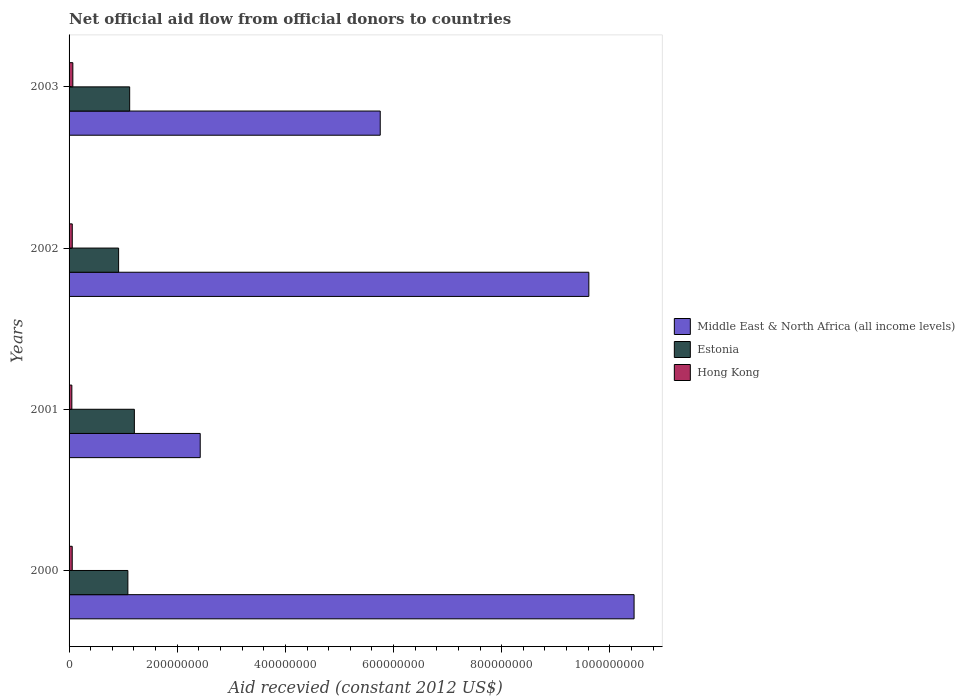How many different coloured bars are there?
Make the answer very short. 3. How many groups of bars are there?
Provide a succinct answer. 4. Are the number of bars per tick equal to the number of legend labels?
Your answer should be compact. Yes. What is the label of the 2nd group of bars from the top?
Offer a terse response. 2002. In how many cases, is the number of bars for a given year not equal to the number of legend labels?
Provide a succinct answer. 0. What is the total aid received in Hong Kong in 2003?
Keep it short and to the point. 6.99e+06. Across all years, what is the maximum total aid received in Hong Kong?
Ensure brevity in your answer.  6.99e+06. Across all years, what is the minimum total aid received in Estonia?
Make the answer very short. 9.16e+07. In which year was the total aid received in Hong Kong minimum?
Make the answer very short. 2001. What is the total total aid received in Hong Kong in the graph?
Your answer should be compact. 2.39e+07. What is the difference between the total aid received in Middle East & North Africa (all income levels) in 2001 and that in 2002?
Make the answer very short. -7.19e+08. What is the difference between the total aid received in Middle East & North Africa (all income levels) in 2001 and the total aid received in Hong Kong in 2002?
Your response must be concise. 2.37e+08. What is the average total aid received in Hong Kong per year?
Ensure brevity in your answer.  5.96e+06. In the year 2003, what is the difference between the total aid received in Hong Kong and total aid received in Middle East & North Africa (all income levels)?
Your answer should be very brief. -5.68e+08. In how many years, is the total aid received in Hong Kong greater than 840000000 US$?
Offer a terse response. 0. What is the ratio of the total aid received in Estonia in 2000 to that in 2001?
Provide a short and direct response. 0.9. Is the total aid received in Estonia in 2000 less than that in 2001?
Keep it short and to the point. Yes. Is the difference between the total aid received in Hong Kong in 2002 and 2003 greater than the difference between the total aid received in Middle East & North Africa (all income levels) in 2002 and 2003?
Offer a very short reply. No. What is the difference between the highest and the second highest total aid received in Hong Kong?
Ensure brevity in your answer.  1.07e+06. What is the difference between the highest and the lowest total aid received in Estonia?
Your answer should be compact. 2.91e+07. In how many years, is the total aid received in Estonia greater than the average total aid received in Estonia taken over all years?
Your response must be concise. 3. What does the 2nd bar from the top in 2001 represents?
Give a very brief answer. Estonia. What does the 2nd bar from the bottom in 2001 represents?
Offer a very short reply. Estonia. Does the graph contain any zero values?
Give a very brief answer. No. What is the title of the graph?
Ensure brevity in your answer.  Net official aid flow from official donors to countries. Does "Kiribati" appear as one of the legend labels in the graph?
Offer a very short reply. No. What is the label or title of the X-axis?
Give a very brief answer. Aid recevied (constant 2012 US$). What is the Aid recevied (constant 2012 US$) of Middle East & North Africa (all income levels) in 2000?
Make the answer very short. 1.04e+09. What is the Aid recevied (constant 2012 US$) of Estonia in 2000?
Provide a short and direct response. 1.09e+08. What is the Aid recevied (constant 2012 US$) of Hong Kong in 2000?
Offer a very short reply. 5.83e+06. What is the Aid recevied (constant 2012 US$) in Middle East & North Africa (all income levels) in 2001?
Your answer should be very brief. 2.43e+08. What is the Aid recevied (constant 2012 US$) in Estonia in 2001?
Make the answer very short. 1.21e+08. What is the Aid recevied (constant 2012 US$) of Hong Kong in 2001?
Give a very brief answer. 5.12e+06. What is the Aid recevied (constant 2012 US$) of Middle East & North Africa (all income levels) in 2002?
Keep it short and to the point. 9.61e+08. What is the Aid recevied (constant 2012 US$) of Estonia in 2002?
Your response must be concise. 9.16e+07. What is the Aid recevied (constant 2012 US$) in Hong Kong in 2002?
Make the answer very short. 5.92e+06. What is the Aid recevied (constant 2012 US$) in Middle East & North Africa (all income levels) in 2003?
Your response must be concise. 5.75e+08. What is the Aid recevied (constant 2012 US$) in Estonia in 2003?
Ensure brevity in your answer.  1.12e+08. What is the Aid recevied (constant 2012 US$) in Hong Kong in 2003?
Give a very brief answer. 6.99e+06. Across all years, what is the maximum Aid recevied (constant 2012 US$) in Middle East & North Africa (all income levels)?
Provide a short and direct response. 1.04e+09. Across all years, what is the maximum Aid recevied (constant 2012 US$) in Estonia?
Provide a succinct answer. 1.21e+08. Across all years, what is the maximum Aid recevied (constant 2012 US$) of Hong Kong?
Give a very brief answer. 6.99e+06. Across all years, what is the minimum Aid recevied (constant 2012 US$) in Middle East & North Africa (all income levels)?
Your response must be concise. 2.43e+08. Across all years, what is the minimum Aid recevied (constant 2012 US$) in Estonia?
Offer a terse response. 9.16e+07. Across all years, what is the minimum Aid recevied (constant 2012 US$) of Hong Kong?
Ensure brevity in your answer.  5.12e+06. What is the total Aid recevied (constant 2012 US$) of Middle East & North Africa (all income levels) in the graph?
Your answer should be very brief. 2.82e+09. What is the total Aid recevied (constant 2012 US$) of Estonia in the graph?
Your answer should be compact. 4.33e+08. What is the total Aid recevied (constant 2012 US$) of Hong Kong in the graph?
Offer a very short reply. 2.39e+07. What is the difference between the Aid recevied (constant 2012 US$) in Middle East & North Africa (all income levels) in 2000 and that in 2001?
Offer a terse response. 8.02e+08. What is the difference between the Aid recevied (constant 2012 US$) in Estonia in 2000 and that in 2001?
Ensure brevity in your answer.  -1.20e+07. What is the difference between the Aid recevied (constant 2012 US$) in Hong Kong in 2000 and that in 2001?
Offer a terse response. 7.10e+05. What is the difference between the Aid recevied (constant 2012 US$) of Middle East & North Africa (all income levels) in 2000 and that in 2002?
Ensure brevity in your answer.  8.36e+07. What is the difference between the Aid recevied (constant 2012 US$) in Estonia in 2000 and that in 2002?
Your answer should be compact. 1.71e+07. What is the difference between the Aid recevied (constant 2012 US$) of Middle East & North Africa (all income levels) in 2000 and that in 2003?
Offer a terse response. 4.69e+08. What is the difference between the Aid recevied (constant 2012 US$) of Estonia in 2000 and that in 2003?
Give a very brief answer. -3.35e+06. What is the difference between the Aid recevied (constant 2012 US$) of Hong Kong in 2000 and that in 2003?
Keep it short and to the point. -1.16e+06. What is the difference between the Aid recevied (constant 2012 US$) in Middle East & North Africa (all income levels) in 2001 and that in 2002?
Your response must be concise. -7.19e+08. What is the difference between the Aid recevied (constant 2012 US$) in Estonia in 2001 and that in 2002?
Provide a short and direct response. 2.91e+07. What is the difference between the Aid recevied (constant 2012 US$) of Hong Kong in 2001 and that in 2002?
Give a very brief answer. -8.00e+05. What is the difference between the Aid recevied (constant 2012 US$) of Middle East & North Africa (all income levels) in 2001 and that in 2003?
Make the answer very short. -3.33e+08. What is the difference between the Aid recevied (constant 2012 US$) of Estonia in 2001 and that in 2003?
Provide a short and direct response. 8.66e+06. What is the difference between the Aid recevied (constant 2012 US$) of Hong Kong in 2001 and that in 2003?
Offer a terse response. -1.87e+06. What is the difference between the Aid recevied (constant 2012 US$) of Middle East & North Africa (all income levels) in 2002 and that in 2003?
Offer a terse response. 3.86e+08. What is the difference between the Aid recevied (constant 2012 US$) in Estonia in 2002 and that in 2003?
Offer a very short reply. -2.05e+07. What is the difference between the Aid recevied (constant 2012 US$) of Hong Kong in 2002 and that in 2003?
Make the answer very short. -1.07e+06. What is the difference between the Aid recevied (constant 2012 US$) of Middle East & North Africa (all income levels) in 2000 and the Aid recevied (constant 2012 US$) of Estonia in 2001?
Keep it short and to the point. 9.24e+08. What is the difference between the Aid recevied (constant 2012 US$) in Middle East & North Africa (all income levels) in 2000 and the Aid recevied (constant 2012 US$) in Hong Kong in 2001?
Your response must be concise. 1.04e+09. What is the difference between the Aid recevied (constant 2012 US$) of Estonia in 2000 and the Aid recevied (constant 2012 US$) of Hong Kong in 2001?
Your answer should be very brief. 1.04e+08. What is the difference between the Aid recevied (constant 2012 US$) of Middle East & North Africa (all income levels) in 2000 and the Aid recevied (constant 2012 US$) of Estonia in 2002?
Provide a succinct answer. 9.53e+08. What is the difference between the Aid recevied (constant 2012 US$) of Middle East & North Africa (all income levels) in 2000 and the Aid recevied (constant 2012 US$) of Hong Kong in 2002?
Make the answer very short. 1.04e+09. What is the difference between the Aid recevied (constant 2012 US$) of Estonia in 2000 and the Aid recevied (constant 2012 US$) of Hong Kong in 2002?
Your answer should be very brief. 1.03e+08. What is the difference between the Aid recevied (constant 2012 US$) in Middle East & North Africa (all income levels) in 2000 and the Aid recevied (constant 2012 US$) in Estonia in 2003?
Keep it short and to the point. 9.33e+08. What is the difference between the Aid recevied (constant 2012 US$) of Middle East & North Africa (all income levels) in 2000 and the Aid recevied (constant 2012 US$) of Hong Kong in 2003?
Offer a terse response. 1.04e+09. What is the difference between the Aid recevied (constant 2012 US$) in Estonia in 2000 and the Aid recevied (constant 2012 US$) in Hong Kong in 2003?
Your answer should be compact. 1.02e+08. What is the difference between the Aid recevied (constant 2012 US$) of Middle East & North Africa (all income levels) in 2001 and the Aid recevied (constant 2012 US$) of Estonia in 2002?
Make the answer very short. 1.51e+08. What is the difference between the Aid recevied (constant 2012 US$) of Middle East & North Africa (all income levels) in 2001 and the Aid recevied (constant 2012 US$) of Hong Kong in 2002?
Your answer should be compact. 2.37e+08. What is the difference between the Aid recevied (constant 2012 US$) in Estonia in 2001 and the Aid recevied (constant 2012 US$) in Hong Kong in 2002?
Offer a terse response. 1.15e+08. What is the difference between the Aid recevied (constant 2012 US$) in Middle East & North Africa (all income levels) in 2001 and the Aid recevied (constant 2012 US$) in Estonia in 2003?
Provide a short and direct response. 1.30e+08. What is the difference between the Aid recevied (constant 2012 US$) of Middle East & North Africa (all income levels) in 2001 and the Aid recevied (constant 2012 US$) of Hong Kong in 2003?
Give a very brief answer. 2.36e+08. What is the difference between the Aid recevied (constant 2012 US$) of Estonia in 2001 and the Aid recevied (constant 2012 US$) of Hong Kong in 2003?
Your answer should be compact. 1.14e+08. What is the difference between the Aid recevied (constant 2012 US$) of Middle East & North Africa (all income levels) in 2002 and the Aid recevied (constant 2012 US$) of Estonia in 2003?
Ensure brevity in your answer.  8.49e+08. What is the difference between the Aid recevied (constant 2012 US$) of Middle East & North Africa (all income levels) in 2002 and the Aid recevied (constant 2012 US$) of Hong Kong in 2003?
Provide a short and direct response. 9.54e+08. What is the difference between the Aid recevied (constant 2012 US$) in Estonia in 2002 and the Aid recevied (constant 2012 US$) in Hong Kong in 2003?
Provide a short and direct response. 8.46e+07. What is the average Aid recevied (constant 2012 US$) of Middle East & North Africa (all income levels) per year?
Provide a succinct answer. 7.06e+08. What is the average Aid recevied (constant 2012 US$) in Estonia per year?
Provide a short and direct response. 1.08e+08. What is the average Aid recevied (constant 2012 US$) in Hong Kong per year?
Offer a very short reply. 5.96e+06. In the year 2000, what is the difference between the Aid recevied (constant 2012 US$) of Middle East & North Africa (all income levels) and Aid recevied (constant 2012 US$) of Estonia?
Your answer should be compact. 9.36e+08. In the year 2000, what is the difference between the Aid recevied (constant 2012 US$) in Middle East & North Africa (all income levels) and Aid recevied (constant 2012 US$) in Hong Kong?
Your answer should be very brief. 1.04e+09. In the year 2000, what is the difference between the Aid recevied (constant 2012 US$) of Estonia and Aid recevied (constant 2012 US$) of Hong Kong?
Provide a short and direct response. 1.03e+08. In the year 2001, what is the difference between the Aid recevied (constant 2012 US$) of Middle East & North Africa (all income levels) and Aid recevied (constant 2012 US$) of Estonia?
Provide a short and direct response. 1.22e+08. In the year 2001, what is the difference between the Aid recevied (constant 2012 US$) of Middle East & North Africa (all income levels) and Aid recevied (constant 2012 US$) of Hong Kong?
Give a very brief answer. 2.37e+08. In the year 2001, what is the difference between the Aid recevied (constant 2012 US$) in Estonia and Aid recevied (constant 2012 US$) in Hong Kong?
Keep it short and to the point. 1.16e+08. In the year 2002, what is the difference between the Aid recevied (constant 2012 US$) in Middle East & North Africa (all income levels) and Aid recevied (constant 2012 US$) in Estonia?
Provide a short and direct response. 8.70e+08. In the year 2002, what is the difference between the Aid recevied (constant 2012 US$) of Middle East & North Africa (all income levels) and Aid recevied (constant 2012 US$) of Hong Kong?
Give a very brief answer. 9.55e+08. In the year 2002, what is the difference between the Aid recevied (constant 2012 US$) in Estonia and Aid recevied (constant 2012 US$) in Hong Kong?
Give a very brief answer. 8.57e+07. In the year 2003, what is the difference between the Aid recevied (constant 2012 US$) in Middle East & North Africa (all income levels) and Aid recevied (constant 2012 US$) in Estonia?
Make the answer very short. 4.63e+08. In the year 2003, what is the difference between the Aid recevied (constant 2012 US$) in Middle East & North Africa (all income levels) and Aid recevied (constant 2012 US$) in Hong Kong?
Give a very brief answer. 5.68e+08. In the year 2003, what is the difference between the Aid recevied (constant 2012 US$) in Estonia and Aid recevied (constant 2012 US$) in Hong Kong?
Ensure brevity in your answer.  1.05e+08. What is the ratio of the Aid recevied (constant 2012 US$) of Middle East & North Africa (all income levels) in 2000 to that in 2001?
Keep it short and to the point. 4.31. What is the ratio of the Aid recevied (constant 2012 US$) in Estonia in 2000 to that in 2001?
Make the answer very short. 0.9. What is the ratio of the Aid recevied (constant 2012 US$) in Hong Kong in 2000 to that in 2001?
Offer a terse response. 1.14. What is the ratio of the Aid recevied (constant 2012 US$) in Middle East & North Africa (all income levels) in 2000 to that in 2002?
Ensure brevity in your answer.  1.09. What is the ratio of the Aid recevied (constant 2012 US$) of Estonia in 2000 to that in 2002?
Provide a short and direct response. 1.19. What is the ratio of the Aid recevied (constant 2012 US$) in Middle East & North Africa (all income levels) in 2000 to that in 2003?
Your answer should be compact. 1.82. What is the ratio of the Aid recevied (constant 2012 US$) in Estonia in 2000 to that in 2003?
Make the answer very short. 0.97. What is the ratio of the Aid recevied (constant 2012 US$) of Hong Kong in 2000 to that in 2003?
Give a very brief answer. 0.83. What is the ratio of the Aid recevied (constant 2012 US$) in Middle East & North Africa (all income levels) in 2001 to that in 2002?
Give a very brief answer. 0.25. What is the ratio of the Aid recevied (constant 2012 US$) of Estonia in 2001 to that in 2002?
Make the answer very short. 1.32. What is the ratio of the Aid recevied (constant 2012 US$) of Hong Kong in 2001 to that in 2002?
Give a very brief answer. 0.86. What is the ratio of the Aid recevied (constant 2012 US$) in Middle East & North Africa (all income levels) in 2001 to that in 2003?
Keep it short and to the point. 0.42. What is the ratio of the Aid recevied (constant 2012 US$) of Estonia in 2001 to that in 2003?
Your answer should be compact. 1.08. What is the ratio of the Aid recevied (constant 2012 US$) in Hong Kong in 2001 to that in 2003?
Provide a succinct answer. 0.73. What is the ratio of the Aid recevied (constant 2012 US$) of Middle East & North Africa (all income levels) in 2002 to that in 2003?
Make the answer very short. 1.67. What is the ratio of the Aid recevied (constant 2012 US$) of Estonia in 2002 to that in 2003?
Provide a succinct answer. 0.82. What is the ratio of the Aid recevied (constant 2012 US$) in Hong Kong in 2002 to that in 2003?
Your answer should be compact. 0.85. What is the difference between the highest and the second highest Aid recevied (constant 2012 US$) in Middle East & North Africa (all income levels)?
Keep it short and to the point. 8.36e+07. What is the difference between the highest and the second highest Aid recevied (constant 2012 US$) in Estonia?
Provide a succinct answer. 8.66e+06. What is the difference between the highest and the second highest Aid recevied (constant 2012 US$) in Hong Kong?
Keep it short and to the point. 1.07e+06. What is the difference between the highest and the lowest Aid recevied (constant 2012 US$) of Middle East & North Africa (all income levels)?
Provide a succinct answer. 8.02e+08. What is the difference between the highest and the lowest Aid recevied (constant 2012 US$) of Estonia?
Offer a very short reply. 2.91e+07. What is the difference between the highest and the lowest Aid recevied (constant 2012 US$) of Hong Kong?
Ensure brevity in your answer.  1.87e+06. 